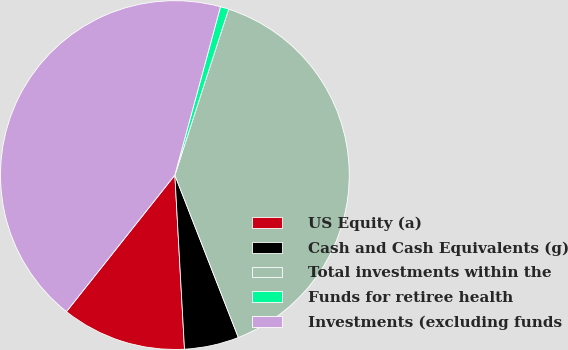Convert chart. <chart><loc_0><loc_0><loc_500><loc_500><pie_chart><fcel>US Equity (a)<fcel>Cash and Cash Equivalents (g)<fcel>Total investments within the<fcel>Funds for retiree health<fcel>Investments (excluding funds<nl><fcel>11.56%<fcel>5.05%<fcel>39.08%<fcel>0.78%<fcel>43.53%<nl></chart> 